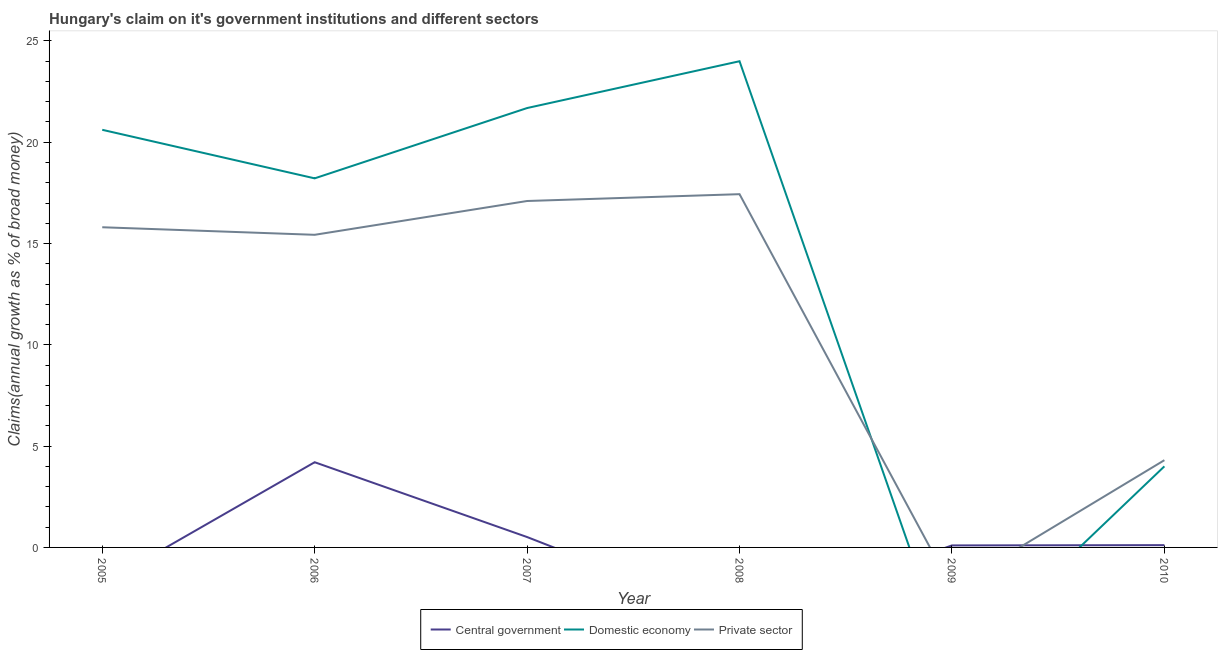Does the line corresponding to percentage of claim on the domestic economy intersect with the line corresponding to percentage of claim on the central government?
Keep it short and to the point. Yes. What is the percentage of claim on the domestic economy in 2006?
Make the answer very short. 18.22. Across all years, what is the maximum percentage of claim on the domestic economy?
Provide a short and direct response. 24. Across all years, what is the minimum percentage of claim on the central government?
Keep it short and to the point. 0. What is the total percentage of claim on the private sector in the graph?
Your answer should be very brief. 70.08. What is the difference between the percentage of claim on the domestic economy in 2006 and that in 2007?
Provide a succinct answer. -3.47. What is the difference between the percentage of claim on the domestic economy in 2010 and the percentage of claim on the private sector in 2009?
Ensure brevity in your answer.  4. What is the average percentage of claim on the central government per year?
Provide a short and direct response. 0.82. In the year 2010, what is the difference between the percentage of claim on the private sector and percentage of claim on the central government?
Keep it short and to the point. 4.19. What is the ratio of the percentage of claim on the central government in 2006 to that in 2009?
Your answer should be very brief. 42.38. Is the difference between the percentage of claim on the private sector in 2006 and 2007 greater than the difference between the percentage of claim on the domestic economy in 2006 and 2007?
Offer a terse response. Yes. What is the difference between the highest and the second highest percentage of claim on the private sector?
Give a very brief answer. 0.34. What is the difference between the highest and the lowest percentage of claim on the central government?
Keep it short and to the point. 4.21. How many lines are there?
Keep it short and to the point. 3. What is the difference between two consecutive major ticks on the Y-axis?
Provide a succinct answer. 5. Does the graph contain grids?
Provide a succinct answer. No. How are the legend labels stacked?
Make the answer very short. Horizontal. What is the title of the graph?
Provide a succinct answer. Hungary's claim on it's government institutions and different sectors. What is the label or title of the X-axis?
Your answer should be very brief. Year. What is the label or title of the Y-axis?
Offer a very short reply. Claims(annual growth as % of broad money). What is the Claims(annual growth as % of broad money) of Central government in 2005?
Make the answer very short. 0. What is the Claims(annual growth as % of broad money) of Domestic economy in 2005?
Your answer should be compact. 20.61. What is the Claims(annual growth as % of broad money) in Private sector in 2005?
Give a very brief answer. 15.8. What is the Claims(annual growth as % of broad money) of Central government in 2006?
Your response must be concise. 4.21. What is the Claims(annual growth as % of broad money) in Domestic economy in 2006?
Your answer should be very brief. 18.22. What is the Claims(annual growth as % of broad money) of Private sector in 2006?
Provide a succinct answer. 15.43. What is the Claims(annual growth as % of broad money) of Central government in 2007?
Provide a short and direct response. 0.51. What is the Claims(annual growth as % of broad money) of Domestic economy in 2007?
Give a very brief answer. 21.69. What is the Claims(annual growth as % of broad money) in Private sector in 2007?
Your response must be concise. 17.1. What is the Claims(annual growth as % of broad money) in Central government in 2008?
Provide a succinct answer. 0. What is the Claims(annual growth as % of broad money) of Domestic economy in 2008?
Make the answer very short. 24. What is the Claims(annual growth as % of broad money) in Private sector in 2008?
Offer a very short reply. 17.44. What is the Claims(annual growth as % of broad money) in Central government in 2009?
Make the answer very short. 0.1. What is the Claims(annual growth as % of broad money) in Central government in 2010?
Ensure brevity in your answer.  0.11. What is the Claims(annual growth as % of broad money) of Domestic economy in 2010?
Ensure brevity in your answer.  4. What is the Claims(annual growth as % of broad money) in Private sector in 2010?
Give a very brief answer. 4.31. Across all years, what is the maximum Claims(annual growth as % of broad money) of Central government?
Provide a short and direct response. 4.21. Across all years, what is the maximum Claims(annual growth as % of broad money) in Domestic economy?
Make the answer very short. 24. Across all years, what is the maximum Claims(annual growth as % of broad money) of Private sector?
Offer a terse response. 17.44. Across all years, what is the minimum Claims(annual growth as % of broad money) of Private sector?
Provide a short and direct response. 0. What is the total Claims(annual growth as % of broad money) in Central government in the graph?
Make the answer very short. 4.93. What is the total Claims(annual growth as % of broad money) of Domestic economy in the graph?
Give a very brief answer. 88.52. What is the total Claims(annual growth as % of broad money) of Private sector in the graph?
Make the answer very short. 70.08. What is the difference between the Claims(annual growth as % of broad money) in Domestic economy in 2005 and that in 2006?
Keep it short and to the point. 2.4. What is the difference between the Claims(annual growth as % of broad money) of Private sector in 2005 and that in 2006?
Provide a short and direct response. 0.37. What is the difference between the Claims(annual growth as % of broad money) of Domestic economy in 2005 and that in 2007?
Offer a very short reply. -1.07. What is the difference between the Claims(annual growth as % of broad money) of Private sector in 2005 and that in 2007?
Your answer should be very brief. -1.3. What is the difference between the Claims(annual growth as % of broad money) in Domestic economy in 2005 and that in 2008?
Your answer should be compact. -3.38. What is the difference between the Claims(annual growth as % of broad money) of Private sector in 2005 and that in 2008?
Your answer should be compact. -1.63. What is the difference between the Claims(annual growth as % of broad money) of Domestic economy in 2005 and that in 2010?
Provide a succinct answer. 16.61. What is the difference between the Claims(annual growth as % of broad money) of Private sector in 2005 and that in 2010?
Provide a short and direct response. 11.5. What is the difference between the Claims(annual growth as % of broad money) in Central government in 2006 and that in 2007?
Give a very brief answer. 3.69. What is the difference between the Claims(annual growth as % of broad money) of Domestic economy in 2006 and that in 2007?
Offer a very short reply. -3.47. What is the difference between the Claims(annual growth as % of broad money) of Private sector in 2006 and that in 2007?
Your answer should be compact. -1.67. What is the difference between the Claims(annual growth as % of broad money) in Domestic economy in 2006 and that in 2008?
Give a very brief answer. -5.78. What is the difference between the Claims(annual growth as % of broad money) in Private sector in 2006 and that in 2008?
Provide a succinct answer. -2.01. What is the difference between the Claims(annual growth as % of broad money) of Central government in 2006 and that in 2009?
Provide a short and direct response. 4.11. What is the difference between the Claims(annual growth as % of broad money) of Central government in 2006 and that in 2010?
Offer a terse response. 4.09. What is the difference between the Claims(annual growth as % of broad money) of Domestic economy in 2006 and that in 2010?
Keep it short and to the point. 14.22. What is the difference between the Claims(annual growth as % of broad money) in Private sector in 2006 and that in 2010?
Your response must be concise. 11.12. What is the difference between the Claims(annual growth as % of broad money) in Domestic economy in 2007 and that in 2008?
Offer a very short reply. -2.31. What is the difference between the Claims(annual growth as % of broad money) in Private sector in 2007 and that in 2008?
Provide a short and direct response. -0.34. What is the difference between the Claims(annual growth as % of broad money) in Central government in 2007 and that in 2009?
Offer a very short reply. 0.41. What is the difference between the Claims(annual growth as % of broad money) in Central government in 2007 and that in 2010?
Your answer should be compact. 0.4. What is the difference between the Claims(annual growth as % of broad money) in Domestic economy in 2007 and that in 2010?
Provide a succinct answer. 17.69. What is the difference between the Claims(annual growth as % of broad money) of Private sector in 2007 and that in 2010?
Offer a terse response. 12.79. What is the difference between the Claims(annual growth as % of broad money) in Domestic economy in 2008 and that in 2010?
Provide a succinct answer. 20. What is the difference between the Claims(annual growth as % of broad money) in Private sector in 2008 and that in 2010?
Provide a short and direct response. 13.13. What is the difference between the Claims(annual growth as % of broad money) in Central government in 2009 and that in 2010?
Provide a succinct answer. -0.01. What is the difference between the Claims(annual growth as % of broad money) of Domestic economy in 2005 and the Claims(annual growth as % of broad money) of Private sector in 2006?
Offer a very short reply. 5.18. What is the difference between the Claims(annual growth as % of broad money) of Domestic economy in 2005 and the Claims(annual growth as % of broad money) of Private sector in 2007?
Provide a short and direct response. 3.51. What is the difference between the Claims(annual growth as % of broad money) of Domestic economy in 2005 and the Claims(annual growth as % of broad money) of Private sector in 2008?
Offer a very short reply. 3.18. What is the difference between the Claims(annual growth as % of broad money) in Domestic economy in 2005 and the Claims(annual growth as % of broad money) in Private sector in 2010?
Your answer should be very brief. 16.31. What is the difference between the Claims(annual growth as % of broad money) of Central government in 2006 and the Claims(annual growth as % of broad money) of Domestic economy in 2007?
Provide a short and direct response. -17.48. What is the difference between the Claims(annual growth as % of broad money) in Central government in 2006 and the Claims(annual growth as % of broad money) in Private sector in 2007?
Your answer should be very brief. -12.89. What is the difference between the Claims(annual growth as % of broad money) in Domestic economy in 2006 and the Claims(annual growth as % of broad money) in Private sector in 2007?
Provide a succinct answer. 1.12. What is the difference between the Claims(annual growth as % of broad money) of Central government in 2006 and the Claims(annual growth as % of broad money) of Domestic economy in 2008?
Provide a short and direct response. -19.79. What is the difference between the Claims(annual growth as % of broad money) in Central government in 2006 and the Claims(annual growth as % of broad money) in Private sector in 2008?
Your answer should be very brief. -13.23. What is the difference between the Claims(annual growth as % of broad money) in Domestic economy in 2006 and the Claims(annual growth as % of broad money) in Private sector in 2008?
Provide a succinct answer. 0.78. What is the difference between the Claims(annual growth as % of broad money) of Central government in 2006 and the Claims(annual growth as % of broad money) of Domestic economy in 2010?
Offer a terse response. 0.2. What is the difference between the Claims(annual growth as % of broad money) in Central government in 2006 and the Claims(annual growth as % of broad money) in Private sector in 2010?
Give a very brief answer. -0.1. What is the difference between the Claims(annual growth as % of broad money) of Domestic economy in 2006 and the Claims(annual growth as % of broad money) of Private sector in 2010?
Make the answer very short. 13.91. What is the difference between the Claims(annual growth as % of broad money) of Central government in 2007 and the Claims(annual growth as % of broad money) of Domestic economy in 2008?
Your response must be concise. -23.49. What is the difference between the Claims(annual growth as % of broad money) of Central government in 2007 and the Claims(annual growth as % of broad money) of Private sector in 2008?
Offer a terse response. -16.92. What is the difference between the Claims(annual growth as % of broad money) of Domestic economy in 2007 and the Claims(annual growth as % of broad money) of Private sector in 2008?
Offer a very short reply. 4.25. What is the difference between the Claims(annual growth as % of broad money) in Central government in 2007 and the Claims(annual growth as % of broad money) in Domestic economy in 2010?
Offer a very short reply. -3.49. What is the difference between the Claims(annual growth as % of broad money) of Central government in 2007 and the Claims(annual growth as % of broad money) of Private sector in 2010?
Ensure brevity in your answer.  -3.79. What is the difference between the Claims(annual growth as % of broad money) of Domestic economy in 2007 and the Claims(annual growth as % of broad money) of Private sector in 2010?
Give a very brief answer. 17.38. What is the difference between the Claims(annual growth as % of broad money) of Domestic economy in 2008 and the Claims(annual growth as % of broad money) of Private sector in 2010?
Provide a succinct answer. 19.69. What is the difference between the Claims(annual growth as % of broad money) in Central government in 2009 and the Claims(annual growth as % of broad money) in Domestic economy in 2010?
Provide a short and direct response. -3.9. What is the difference between the Claims(annual growth as % of broad money) of Central government in 2009 and the Claims(annual growth as % of broad money) of Private sector in 2010?
Keep it short and to the point. -4.21. What is the average Claims(annual growth as % of broad money) of Central government per year?
Keep it short and to the point. 0.82. What is the average Claims(annual growth as % of broad money) in Domestic economy per year?
Provide a short and direct response. 14.75. What is the average Claims(annual growth as % of broad money) in Private sector per year?
Give a very brief answer. 11.68. In the year 2005, what is the difference between the Claims(annual growth as % of broad money) in Domestic economy and Claims(annual growth as % of broad money) in Private sector?
Your response must be concise. 4.81. In the year 2006, what is the difference between the Claims(annual growth as % of broad money) of Central government and Claims(annual growth as % of broad money) of Domestic economy?
Your answer should be compact. -14.01. In the year 2006, what is the difference between the Claims(annual growth as % of broad money) in Central government and Claims(annual growth as % of broad money) in Private sector?
Ensure brevity in your answer.  -11.23. In the year 2006, what is the difference between the Claims(annual growth as % of broad money) of Domestic economy and Claims(annual growth as % of broad money) of Private sector?
Offer a very short reply. 2.79. In the year 2007, what is the difference between the Claims(annual growth as % of broad money) in Central government and Claims(annual growth as % of broad money) in Domestic economy?
Make the answer very short. -21.18. In the year 2007, what is the difference between the Claims(annual growth as % of broad money) of Central government and Claims(annual growth as % of broad money) of Private sector?
Your response must be concise. -16.59. In the year 2007, what is the difference between the Claims(annual growth as % of broad money) in Domestic economy and Claims(annual growth as % of broad money) in Private sector?
Give a very brief answer. 4.59. In the year 2008, what is the difference between the Claims(annual growth as % of broad money) of Domestic economy and Claims(annual growth as % of broad money) of Private sector?
Keep it short and to the point. 6.56. In the year 2010, what is the difference between the Claims(annual growth as % of broad money) in Central government and Claims(annual growth as % of broad money) in Domestic economy?
Keep it short and to the point. -3.89. In the year 2010, what is the difference between the Claims(annual growth as % of broad money) in Central government and Claims(annual growth as % of broad money) in Private sector?
Make the answer very short. -4.19. In the year 2010, what is the difference between the Claims(annual growth as % of broad money) of Domestic economy and Claims(annual growth as % of broad money) of Private sector?
Give a very brief answer. -0.3. What is the ratio of the Claims(annual growth as % of broad money) of Domestic economy in 2005 to that in 2006?
Give a very brief answer. 1.13. What is the ratio of the Claims(annual growth as % of broad money) of Private sector in 2005 to that in 2006?
Your answer should be compact. 1.02. What is the ratio of the Claims(annual growth as % of broad money) of Domestic economy in 2005 to that in 2007?
Ensure brevity in your answer.  0.95. What is the ratio of the Claims(annual growth as % of broad money) of Private sector in 2005 to that in 2007?
Provide a succinct answer. 0.92. What is the ratio of the Claims(annual growth as % of broad money) in Domestic economy in 2005 to that in 2008?
Provide a succinct answer. 0.86. What is the ratio of the Claims(annual growth as % of broad money) in Private sector in 2005 to that in 2008?
Ensure brevity in your answer.  0.91. What is the ratio of the Claims(annual growth as % of broad money) of Domestic economy in 2005 to that in 2010?
Offer a very short reply. 5.15. What is the ratio of the Claims(annual growth as % of broad money) of Private sector in 2005 to that in 2010?
Ensure brevity in your answer.  3.67. What is the ratio of the Claims(annual growth as % of broad money) in Central government in 2006 to that in 2007?
Offer a very short reply. 8.21. What is the ratio of the Claims(annual growth as % of broad money) in Domestic economy in 2006 to that in 2007?
Provide a short and direct response. 0.84. What is the ratio of the Claims(annual growth as % of broad money) of Private sector in 2006 to that in 2007?
Provide a succinct answer. 0.9. What is the ratio of the Claims(annual growth as % of broad money) of Domestic economy in 2006 to that in 2008?
Provide a short and direct response. 0.76. What is the ratio of the Claims(annual growth as % of broad money) of Private sector in 2006 to that in 2008?
Provide a succinct answer. 0.89. What is the ratio of the Claims(annual growth as % of broad money) of Central government in 2006 to that in 2009?
Keep it short and to the point. 42.38. What is the ratio of the Claims(annual growth as % of broad money) of Central government in 2006 to that in 2010?
Make the answer very short. 37.19. What is the ratio of the Claims(annual growth as % of broad money) of Domestic economy in 2006 to that in 2010?
Provide a short and direct response. 4.55. What is the ratio of the Claims(annual growth as % of broad money) in Private sector in 2006 to that in 2010?
Make the answer very short. 3.58. What is the ratio of the Claims(annual growth as % of broad money) in Domestic economy in 2007 to that in 2008?
Ensure brevity in your answer.  0.9. What is the ratio of the Claims(annual growth as % of broad money) of Private sector in 2007 to that in 2008?
Provide a short and direct response. 0.98. What is the ratio of the Claims(annual growth as % of broad money) in Central government in 2007 to that in 2009?
Keep it short and to the point. 5.16. What is the ratio of the Claims(annual growth as % of broad money) of Central government in 2007 to that in 2010?
Give a very brief answer. 4.53. What is the ratio of the Claims(annual growth as % of broad money) in Domestic economy in 2007 to that in 2010?
Keep it short and to the point. 5.42. What is the ratio of the Claims(annual growth as % of broad money) of Private sector in 2007 to that in 2010?
Ensure brevity in your answer.  3.97. What is the ratio of the Claims(annual growth as % of broad money) of Domestic economy in 2008 to that in 2010?
Your answer should be very brief. 6. What is the ratio of the Claims(annual growth as % of broad money) in Private sector in 2008 to that in 2010?
Offer a terse response. 4.05. What is the ratio of the Claims(annual growth as % of broad money) in Central government in 2009 to that in 2010?
Your answer should be very brief. 0.88. What is the difference between the highest and the second highest Claims(annual growth as % of broad money) of Central government?
Ensure brevity in your answer.  3.69. What is the difference between the highest and the second highest Claims(annual growth as % of broad money) in Domestic economy?
Offer a very short reply. 2.31. What is the difference between the highest and the second highest Claims(annual growth as % of broad money) of Private sector?
Provide a short and direct response. 0.34. What is the difference between the highest and the lowest Claims(annual growth as % of broad money) in Central government?
Provide a succinct answer. 4.21. What is the difference between the highest and the lowest Claims(annual growth as % of broad money) of Domestic economy?
Provide a succinct answer. 24. What is the difference between the highest and the lowest Claims(annual growth as % of broad money) in Private sector?
Make the answer very short. 17.44. 